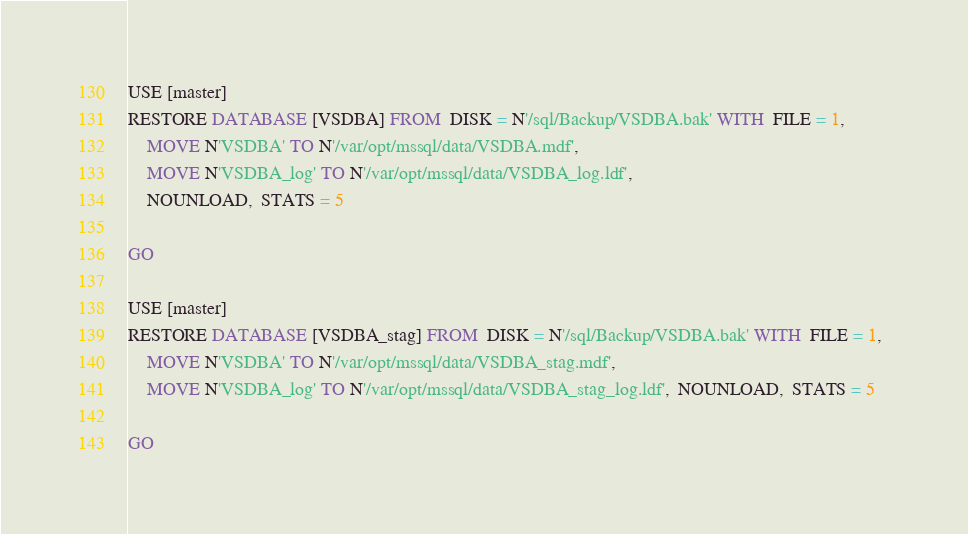<code> <loc_0><loc_0><loc_500><loc_500><_SQL_>USE [master]
RESTORE DATABASE [VSDBA] FROM  DISK = N'/sql/Backup/VSDBA.bak' WITH  FILE = 1,  
	MOVE N'VSDBA' TO N'/var/opt/mssql/data/VSDBA.mdf',  
	MOVE N'VSDBA_log' TO N'/var/opt/mssql/data/VSDBA_log.ldf',  
	NOUNLOAD,  STATS = 5

GO

USE [master]
RESTORE DATABASE [VSDBA_stag] FROM  DISK = N'/sql/Backup/VSDBA.bak' WITH  FILE = 1,  
	MOVE N'VSDBA' TO N'/var/opt/mssql/data/VSDBA_stag.mdf',  
	MOVE N'VSDBA_log' TO N'/var/opt/mssql/data/VSDBA_stag_log.ldf',  NOUNLOAD,  STATS = 5

GO


</code> 